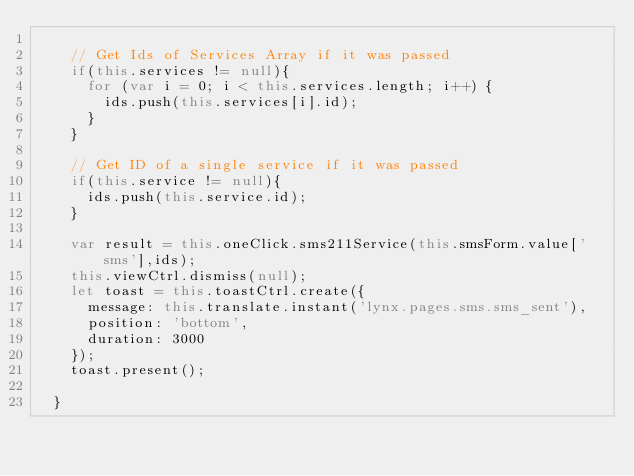<code> <loc_0><loc_0><loc_500><loc_500><_TypeScript_>
    // Get Ids of Services Array if it was passed
    if(this.services != null){
      for (var i = 0; i < this.services.length; i++) {
        ids.push(this.services[i].id);
      }
    }

    // Get ID of a single service if it was passed
    if(this.service != null){
      ids.push(this.service.id);
    }

    var result = this.oneClick.sms211Service(this.smsForm.value['sms'],ids);
    this.viewCtrl.dismiss(null);
    let toast = this.toastCtrl.create({
      message: this.translate.instant('lynx.pages.sms.sms_sent'),
      position: 'bottom',
      duration: 3000
    });
    toast.present();

  }
</code> 